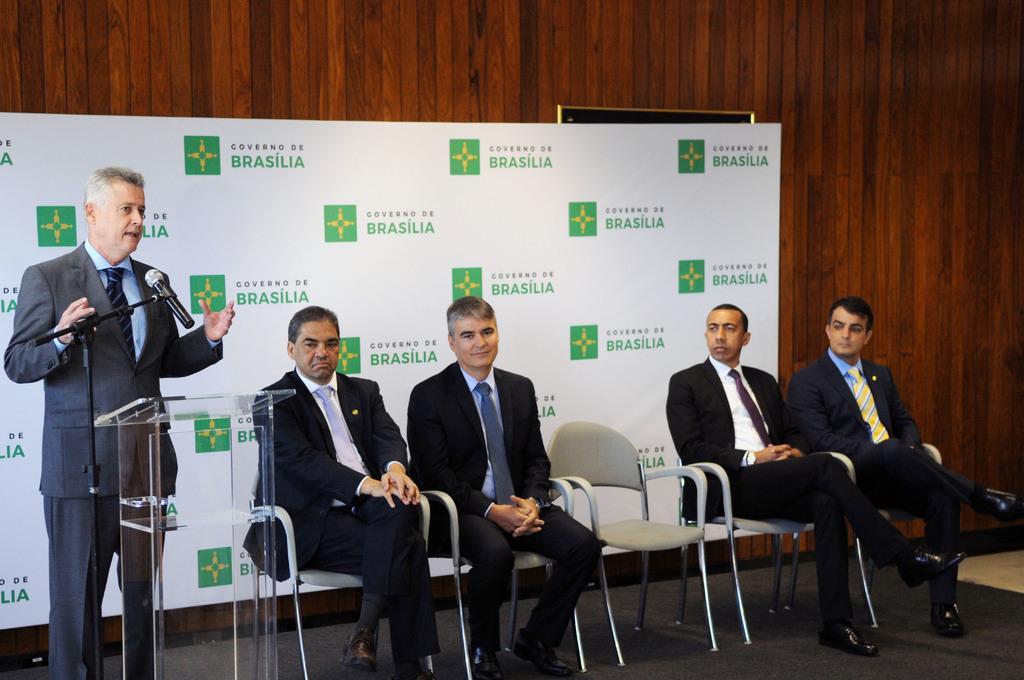In one or two sentences, can you explain what this image depicts? In this image we can see one person standing. Four are sitting on chairs. And there is a stand. And there is a mic with mic stand. In the back there is a wooden wall. Also there is a banner with something written. 